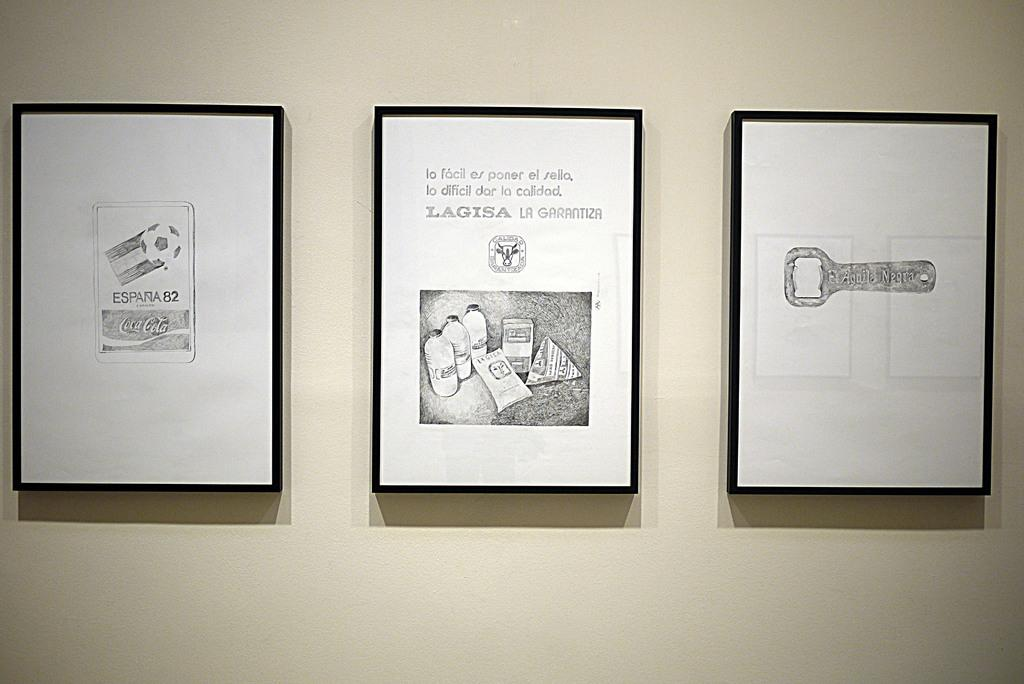<image>
Share a concise interpretation of the image provided. Three drawings are framed on a wall and say Lagisa. 